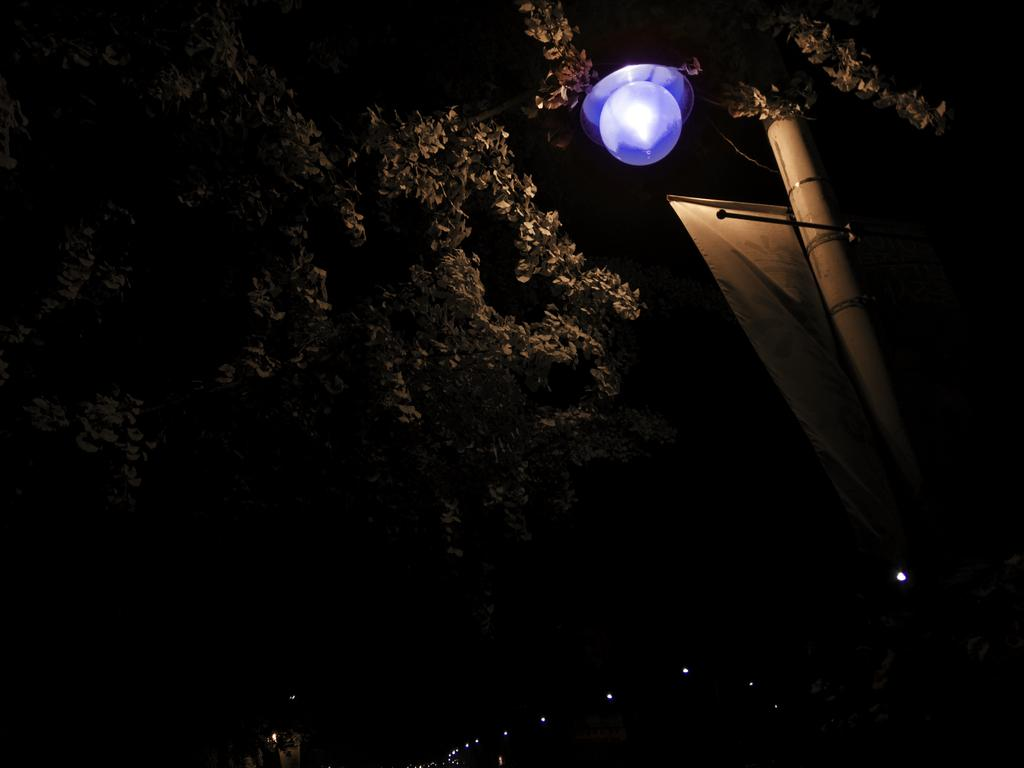What type of vegetation is on the left side of the image? There are trees on the left side of the image. What can be seen in the middle of the image? There is a light in the middle of the image. What is located on the right side of the image? There is a pole and a banner on the right side of the image. How does the tongue of the person in the image affect the experience of the light? There is no person present in the image, and therefore no tongue or experience related to the light can be observed. 